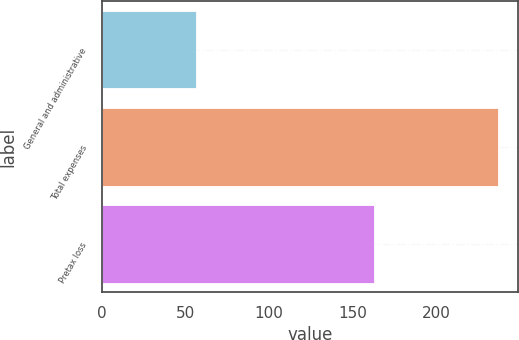<chart> <loc_0><loc_0><loc_500><loc_500><bar_chart><fcel>General and administrative<fcel>Total expenses<fcel>Pretax loss<nl><fcel>56<fcel>237<fcel>163<nl></chart> 